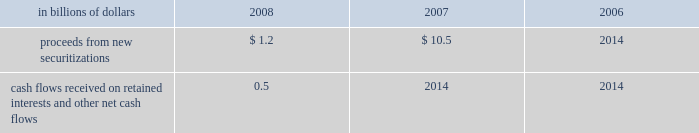Application of specific accounting literature .
For the nonconsolidated proprietary tob trusts and qspe tob trusts , the company recognizes only its residual investment on its balance sheet at fair value and the third-party financing raised by the trusts is off-balance sheet .
The table summarizes selected cash flow information related to municipal bond securitizations for the years 2008 , 2007 and 2006 : in billions of dollars 2008 2007 2006 .
Cash flows received on retained interests and other net cash flows 0.5 2014 2014 municipal investments municipal investment transactions represent partnerships that finance the construction and rehabilitation of low-income affordable rental housing .
The company generally invests in these partnerships as a limited partner and earns a return primarily through the receipt of tax credits earned from the affordable housing investments made by the partnership .
Client intermediation client intermediation transactions represent a range of transactions designed to provide investors with specified returns based on the returns of an underlying security , referenced asset or index .
These transactions include credit-linked notes and equity-linked notes .
In these transactions , the spe typically obtains exposure to the underlying security , referenced asset or index through a derivative instrument , such as a total-return swap or a credit-default swap .
In turn the spe issues notes to investors that pay a return based on the specified underlying security , referenced asset or index .
The spe invests the proceeds in a financial asset or a guaranteed insurance contract ( gic ) that serves as collateral for the derivative contract over the term of the transaction .
The company 2019s involvement in these transactions includes being the counterparty to the spe 2019s derivative instruments and investing in a portion of the notes issued by the spe .
In certain transactions , the investor 2019s maximum risk of loss is limited and the company absorbs risk of loss above a specified level .
The company 2019s maximum risk of loss in these transactions is defined as the amount invested in notes issued by the spe and the notional amount of any risk of loss absorbed by the company through a separate instrument issued by the spe .
The derivative instrument held by the company may generate a receivable from the spe ( for example , where the company purchases credit protection from the spe in connection with the spe 2019s issuance of a credit-linked note ) , which is collateralized by the assets owned by the spe .
These derivative instruments are not considered variable interests under fin 46 ( r ) and any associated receivables are not included in the calculation of maximum exposure to the spe .
Structured investment vehicles structured investment vehicles ( sivs ) are spes that issue junior notes and senior debt ( medium-term notes and short-term commercial paper ) to fund the purchase of high quality assets .
The junior notes are subject to the 201cfirst loss 201d risk of the sivs .
The sivs provide a variable return to the junior note investors based on the net spread between the cost to issue the senior debt and the return realized by the high quality assets .
The company acts as manager for the sivs and , prior to december 13 , 2007 , was not contractually obligated to provide liquidity facilities or guarantees to the sivs .
In response to the ratings review of the outstanding senior debt of the sivs for a possible downgrade announced by two ratings agencies and the continued reduction of liquidity in the siv-related asset-backed commercial paper and medium-term note markets , on december 13 , 2007 , citigroup announced its commitment to provide support facilities that would support the sivs 2019 senior debt ratings .
As a result of this commitment , citigroup became the sivs 2019 primary beneficiary and began consolidating these entities .
On february 12 , 2008 , citigroup finalized the terms of the support facilities , which took the form of a commitment to provide $ 3.5 billion of mezzanine capital to the sivs in the event the market value of their junior notes approaches zero .
The mezzanine capital facility was increased by $ 1 billion to $ 4.5 billion , with the additional commitment funded during the fourth quarter of 2008 .
The facilities rank senior to the junior notes but junior to the commercial paper and medium-term notes .
The facilities were at arm 2019s-length terms .
Interest was paid on the drawn amount of the facilities and a per annum fee was paid on the unused portion .
During the period to november 18 , 2008 , the company wrote down $ 3.3 billion on siv assets .
In order to complete the wind-down of the sivs , the company , in a nearly cashless transaction , purchased the remaining assets of the sivs at fair value , with a trade date of november 18 , 2008 .
The company funded the purchase of the siv assets by assuming the obligation to pay amounts due under the medium-term notes issued by the sivs , as the medium-term notes mature .
The net funding provided by the company to fund the purchase of the siv assets was $ 0.3 billion .
As of december 31 , 2008 , the carrying amount of the purchased siv assets was $ 16.6 billion , of which $ 16.5 billion is classified as htm assets .
Investment funds the company is the investment manager for certain investment funds that invest in various asset classes including private equity , hedge funds , real estate , fixed income and infrastructure .
The company earns a management fee , which is a percentage of capital under management , and may earn performance fees .
In addition , for some of these funds the company has an ownership interest in the investment funds .
The company has also established a number of investment funds as opportunities for qualified employees to invest in private equity investments .
The company acts as investment manager to these funds and may provide employees with financing on both a recourse and non-recourse basis for a portion of the employees 2019 investment commitments. .
What was the percentage change in proceeds from new securitizations from 2007 to 2008? 
Computations: ((1.2 - 10.5) / 10.5)
Answer: -0.88571. 